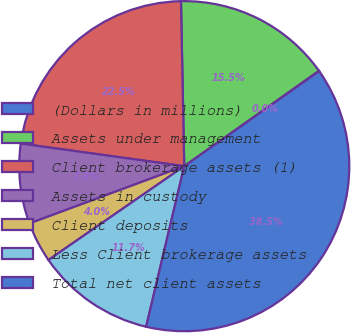<chart> <loc_0><loc_0><loc_500><loc_500><pie_chart><fcel>(Dollars in millions)<fcel>Assets under management<fcel>Client brokerage assets (1)<fcel>Assets in custody<fcel>Client deposits<fcel>Less Client brokerage assets<fcel>Total net client assets<nl><fcel>0.04%<fcel>15.51%<fcel>22.5%<fcel>7.83%<fcel>3.98%<fcel>11.67%<fcel>38.48%<nl></chart> 